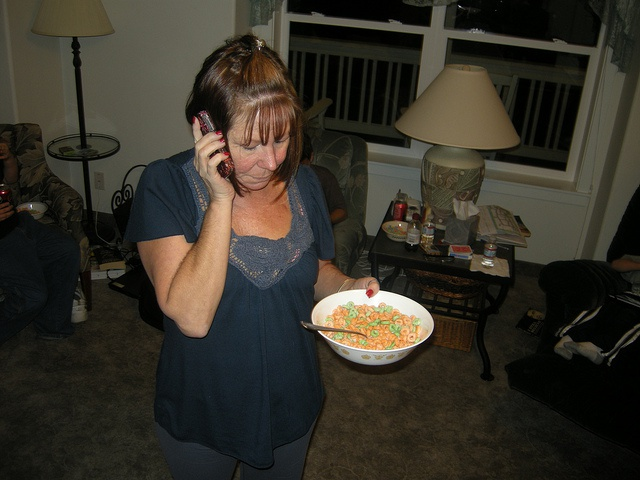Describe the objects in this image and their specific colors. I can see people in black, gray, and tan tones, couch in black, darkgreen, and gray tones, people in black, maroon, and gray tones, bowl in black, ivory, orange, tan, and darkgray tones, and couch in black and maroon tones in this image. 